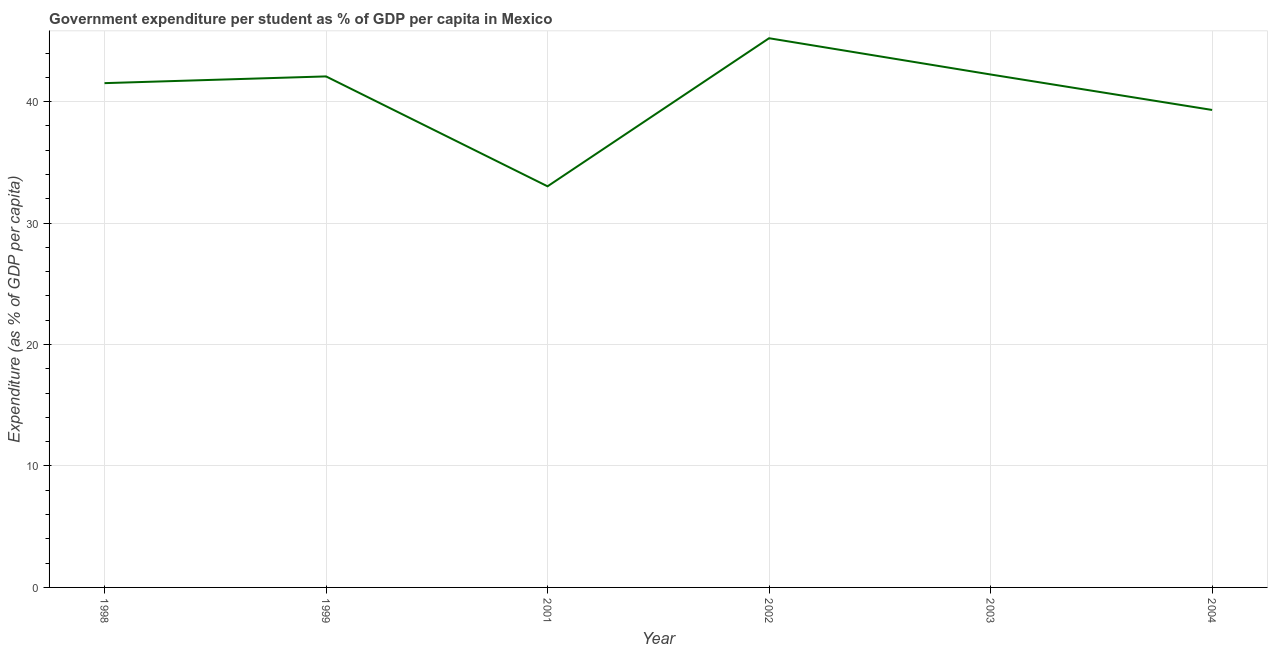What is the government expenditure per student in 2002?
Provide a short and direct response. 45.23. Across all years, what is the maximum government expenditure per student?
Your answer should be very brief. 45.23. Across all years, what is the minimum government expenditure per student?
Your response must be concise. 33.03. In which year was the government expenditure per student maximum?
Offer a very short reply. 2002. In which year was the government expenditure per student minimum?
Ensure brevity in your answer.  2001. What is the sum of the government expenditure per student?
Give a very brief answer. 243.43. What is the difference between the government expenditure per student in 2002 and 2004?
Your answer should be very brief. 5.91. What is the average government expenditure per student per year?
Offer a very short reply. 40.57. What is the median government expenditure per student?
Offer a terse response. 41.8. In how many years, is the government expenditure per student greater than 40 %?
Offer a very short reply. 4. What is the ratio of the government expenditure per student in 1999 to that in 2001?
Provide a succinct answer. 1.27. What is the difference between the highest and the second highest government expenditure per student?
Give a very brief answer. 2.99. Is the sum of the government expenditure per student in 2002 and 2003 greater than the maximum government expenditure per student across all years?
Your response must be concise. Yes. What is the difference between the highest and the lowest government expenditure per student?
Provide a short and direct response. 12.19. In how many years, is the government expenditure per student greater than the average government expenditure per student taken over all years?
Your answer should be compact. 4. Does the government expenditure per student monotonically increase over the years?
Give a very brief answer. No. Does the graph contain grids?
Your answer should be compact. Yes. What is the title of the graph?
Provide a short and direct response. Government expenditure per student as % of GDP per capita in Mexico. What is the label or title of the Y-axis?
Make the answer very short. Expenditure (as % of GDP per capita). What is the Expenditure (as % of GDP per capita) of 1998?
Make the answer very short. 41.53. What is the Expenditure (as % of GDP per capita) of 1999?
Keep it short and to the point. 42.08. What is the Expenditure (as % of GDP per capita) in 2001?
Your answer should be very brief. 33.03. What is the Expenditure (as % of GDP per capita) in 2002?
Your response must be concise. 45.23. What is the Expenditure (as % of GDP per capita) of 2003?
Keep it short and to the point. 42.24. What is the Expenditure (as % of GDP per capita) of 2004?
Offer a terse response. 39.32. What is the difference between the Expenditure (as % of GDP per capita) in 1998 and 1999?
Offer a terse response. -0.55. What is the difference between the Expenditure (as % of GDP per capita) in 1998 and 2001?
Provide a succinct answer. 8.5. What is the difference between the Expenditure (as % of GDP per capita) in 1998 and 2002?
Your answer should be very brief. -3.7. What is the difference between the Expenditure (as % of GDP per capita) in 1998 and 2003?
Provide a succinct answer. -0.71. What is the difference between the Expenditure (as % of GDP per capita) in 1998 and 2004?
Make the answer very short. 2.21. What is the difference between the Expenditure (as % of GDP per capita) in 1999 and 2001?
Your answer should be very brief. 9.05. What is the difference between the Expenditure (as % of GDP per capita) in 1999 and 2002?
Make the answer very short. -3.14. What is the difference between the Expenditure (as % of GDP per capita) in 1999 and 2003?
Your answer should be compact. -0.16. What is the difference between the Expenditure (as % of GDP per capita) in 1999 and 2004?
Keep it short and to the point. 2.76. What is the difference between the Expenditure (as % of GDP per capita) in 2001 and 2002?
Provide a short and direct response. -12.19. What is the difference between the Expenditure (as % of GDP per capita) in 2001 and 2003?
Provide a short and direct response. -9.21. What is the difference between the Expenditure (as % of GDP per capita) in 2001 and 2004?
Ensure brevity in your answer.  -6.29. What is the difference between the Expenditure (as % of GDP per capita) in 2002 and 2003?
Your answer should be very brief. 2.99. What is the difference between the Expenditure (as % of GDP per capita) in 2002 and 2004?
Provide a succinct answer. 5.91. What is the difference between the Expenditure (as % of GDP per capita) in 2003 and 2004?
Provide a short and direct response. 2.92. What is the ratio of the Expenditure (as % of GDP per capita) in 1998 to that in 1999?
Your answer should be very brief. 0.99. What is the ratio of the Expenditure (as % of GDP per capita) in 1998 to that in 2001?
Your response must be concise. 1.26. What is the ratio of the Expenditure (as % of GDP per capita) in 1998 to that in 2002?
Make the answer very short. 0.92. What is the ratio of the Expenditure (as % of GDP per capita) in 1998 to that in 2004?
Give a very brief answer. 1.06. What is the ratio of the Expenditure (as % of GDP per capita) in 1999 to that in 2001?
Ensure brevity in your answer.  1.27. What is the ratio of the Expenditure (as % of GDP per capita) in 1999 to that in 2004?
Your answer should be very brief. 1.07. What is the ratio of the Expenditure (as % of GDP per capita) in 2001 to that in 2002?
Offer a terse response. 0.73. What is the ratio of the Expenditure (as % of GDP per capita) in 2001 to that in 2003?
Your answer should be compact. 0.78. What is the ratio of the Expenditure (as % of GDP per capita) in 2001 to that in 2004?
Provide a succinct answer. 0.84. What is the ratio of the Expenditure (as % of GDP per capita) in 2002 to that in 2003?
Make the answer very short. 1.07. What is the ratio of the Expenditure (as % of GDP per capita) in 2002 to that in 2004?
Your answer should be very brief. 1.15. What is the ratio of the Expenditure (as % of GDP per capita) in 2003 to that in 2004?
Provide a short and direct response. 1.07. 